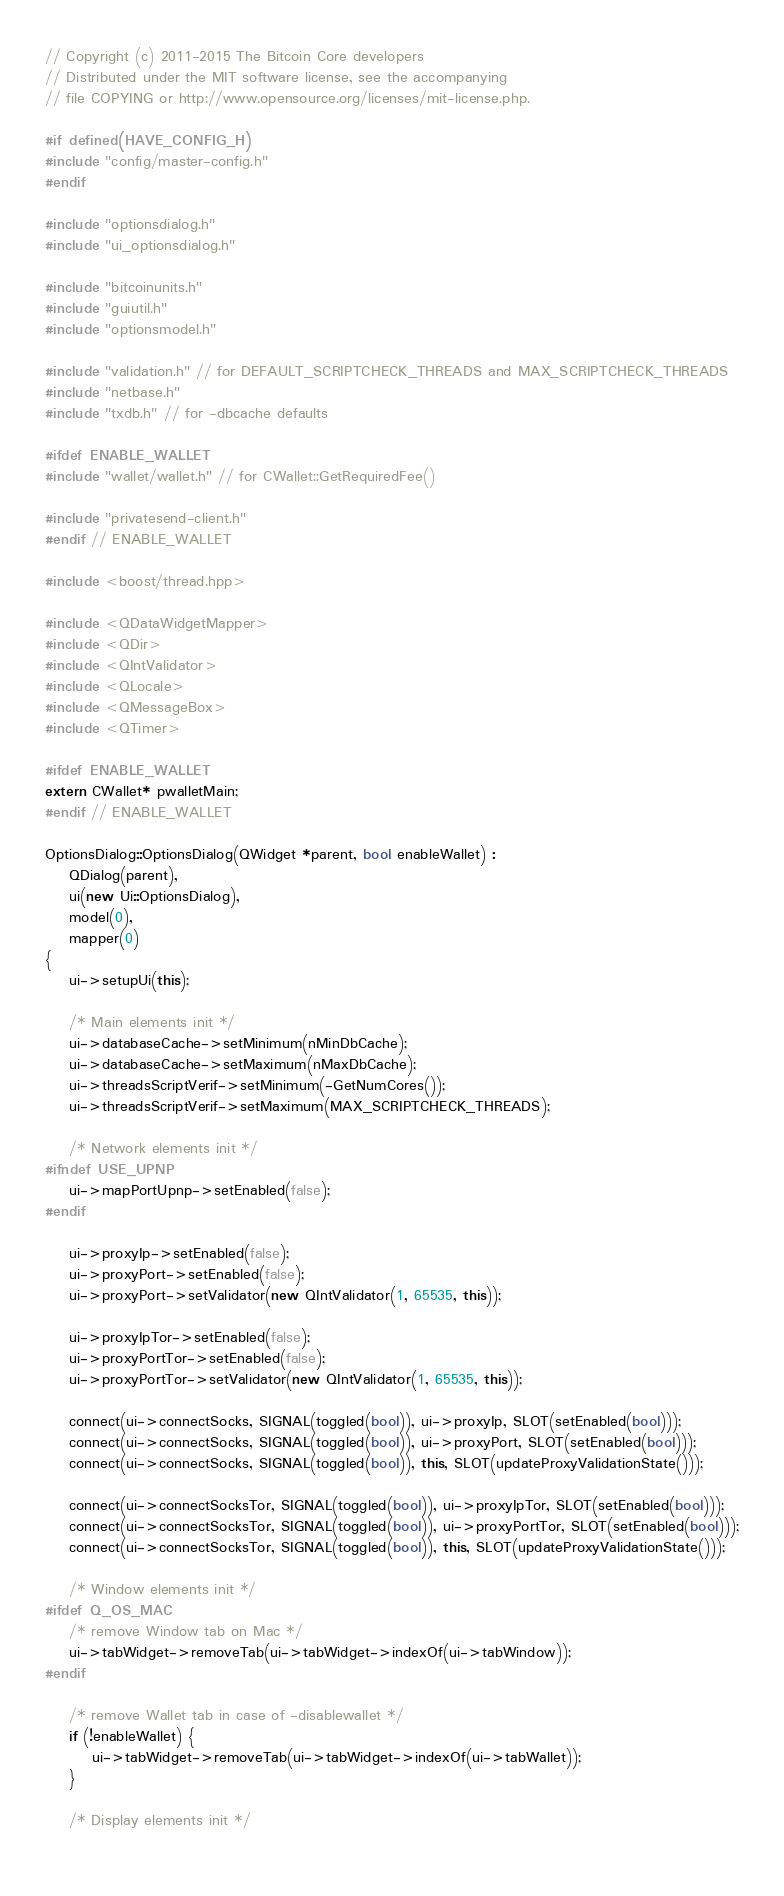Convert code to text. <code><loc_0><loc_0><loc_500><loc_500><_C++_>// Copyright (c) 2011-2015 The Bitcoin Core developers
// Distributed under the MIT software license, see the accompanying
// file COPYING or http://www.opensource.org/licenses/mit-license.php.

#if defined(HAVE_CONFIG_H)
#include "config/master-config.h"
#endif

#include "optionsdialog.h"
#include "ui_optionsdialog.h"

#include "bitcoinunits.h"
#include "guiutil.h"
#include "optionsmodel.h"

#include "validation.h" // for DEFAULT_SCRIPTCHECK_THREADS and MAX_SCRIPTCHECK_THREADS
#include "netbase.h"
#include "txdb.h" // for -dbcache defaults

#ifdef ENABLE_WALLET
#include "wallet/wallet.h" // for CWallet::GetRequiredFee()

#include "privatesend-client.h"
#endif // ENABLE_WALLET

#include <boost/thread.hpp>

#include <QDataWidgetMapper>
#include <QDir>
#include <QIntValidator>
#include <QLocale>
#include <QMessageBox>
#include <QTimer>

#ifdef ENABLE_WALLET
extern CWallet* pwalletMain;
#endif // ENABLE_WALLET

OptionsDialog::OptionsDialog(QWidget *parent, bool enableWallet) :
    QDialog(parent),
    ui(new Ui::OptionsDialog),
    model(0),
    mapper(0)
{
    ui->setupUi(this);

    /* Main elements init */
    ui->databaseCache->setMinimum(nMinDbCache);
    ui->databaseCache->setMaximum(nMaxDbCache);
    ui->threadsScriptVerif->setMinimum(-GetNumCores());
    ui->threadsScriptVerif->setMaximum(MAX_SCRIPTCHECK_THREADS);

    /* Network elements init */
#ifndef USE_UPNP
    ui->mapPortUpnp->setEnabled(false);
#endif

    ui->proxyIp->setEnabled(false);
    ui->proxyPort->setEnabled(false);
    ui->proxyPort->setValidator(new QIntValidator(1, 65535, this));

    ui->proxyIpTor->setEnabled(false);
    ui->proxyPortTor->setEnabled(false);
    ui->proxyPortTor->setValidator(new QIntValidator(1, 65535, this));

    connect(ui->connectSocks, SIGNAL(toggled(bool)), ui->proxyIp, SLOT(setEnabled(bool)));
    connect(ui->connectSocks, SIGNAL(toggled(bool)), ui->proxyPort, SLOT(setEnabled(bool)));
    connect(ui->connectSocks, SIGNAL(toggled(bool)), this, SLOT(updateProxyValidationState()));

    connect(ui->connectSocksTor, SIGNAL(toggled(bool)), ui->proxyIpTor, SLOT(setEnabled(bool)));
    connect(ui->connectSocksTor, SIGNAL(toggled(bool)), ui->proxyPortTor, SLOT(setEnabled(bool)));
    connect(ui->connectSocksTor, SIGNAL(toggled(bool)), this, SLOT(updateProxyValidationState()));

    /* Window elements init */
#ifdef Q_OS_MAC
    /* remove Window tab on Mac */
    ui->tabWidget->removeTab(ui->tabWidget->indexOf(ui->tabWindow));
#endif

    /* remove Wallet tab in case of -disablewallet */
    if (!enableWallet) {
        ui->tabWidget->removeTab(ui->tabWidget->indexOf(ui->tabWallet));
    }

    /* Display elements init */
    </code> 